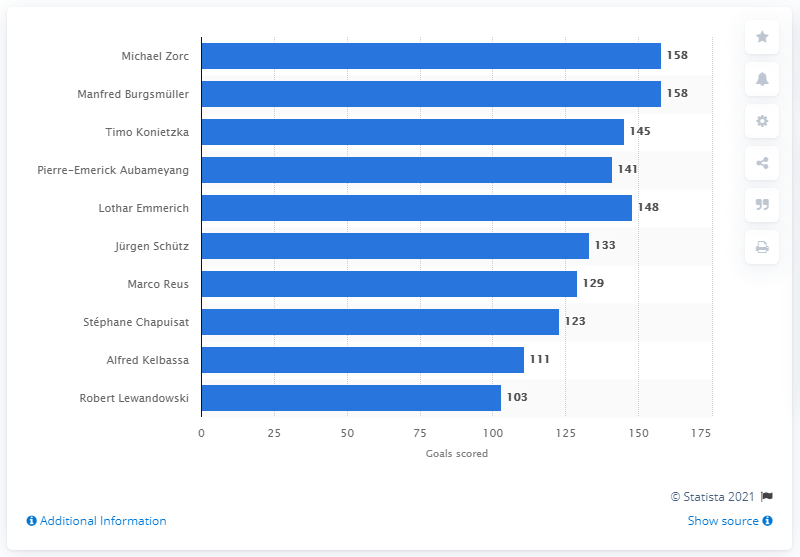Outline some significant characteristics in this image. In the given text, it is stated that Michael Zorc and Manfred Burgsm14ller scored a total of 158 goals. 